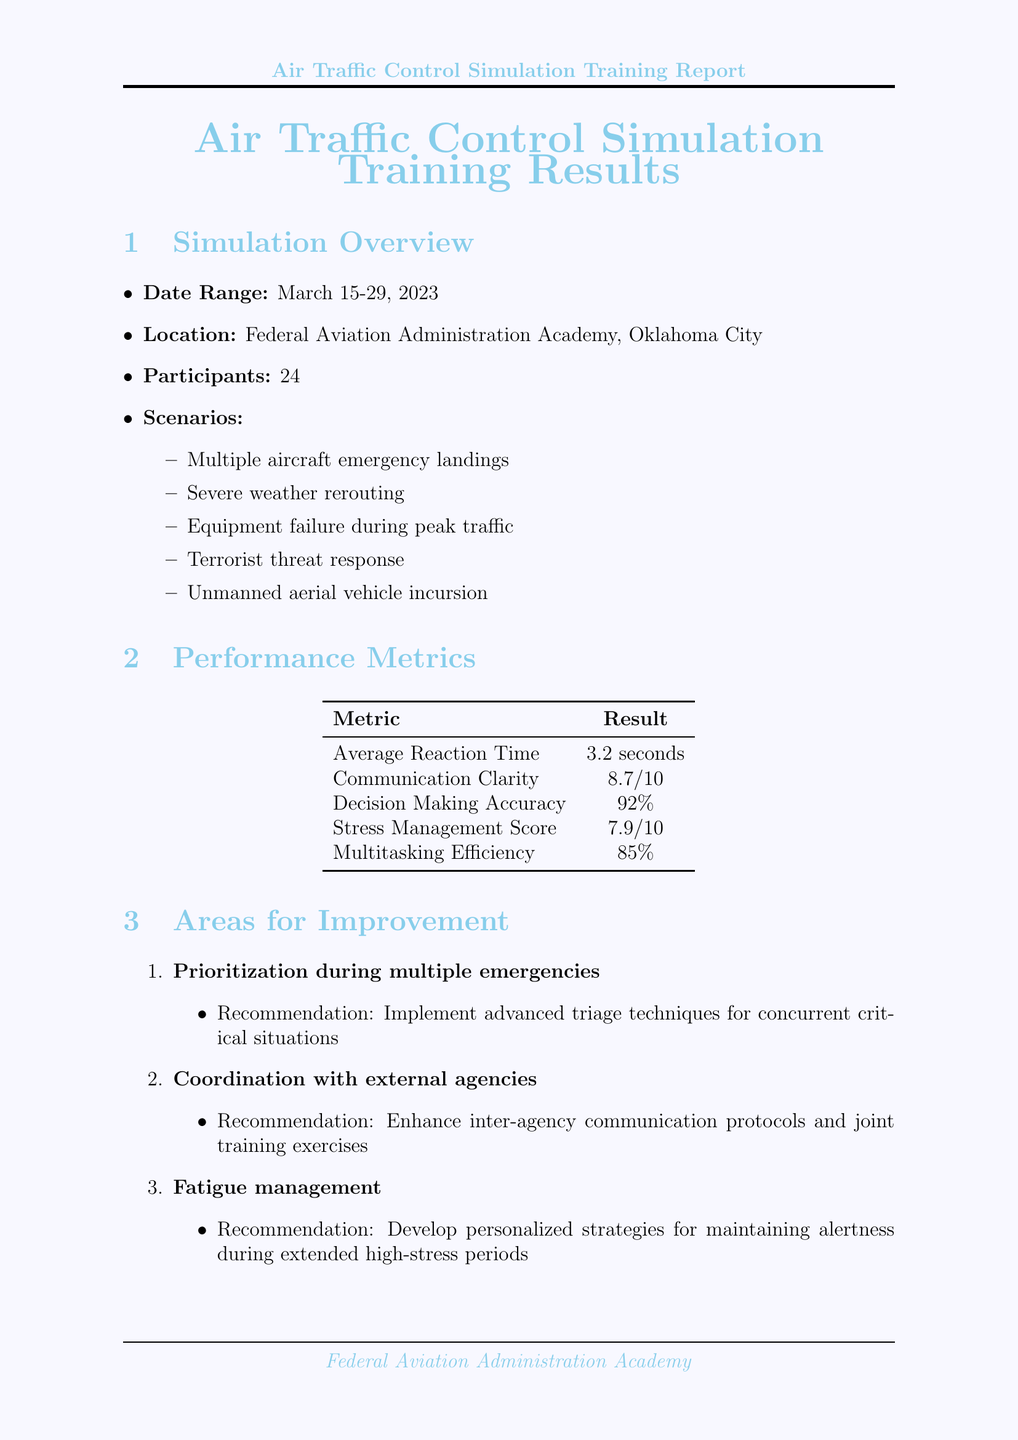What was the date range of the simulations? The date range is specified in the section titled "Simulation Overview," which details the period of the simulations as March 15-29, 2023.
Answer: March 15-29, 2023 What was the average reaction time reported? The average reaction time is mentioned in the "Performance Metrics" table and is a direct performance measure provided.
Answer: 3.2 seconds How many participants were involved in the simulations? The number of participants is listed in the "Simulation Overview" section and refers to the total count for the training.
Answer: 24 Which scenario received commendations for quick decision making? The commendation for quick decision making relates to the scenario that involved severe weather rerouting, as noted in the "Commendations" section.
Answer: Severe weather rerouting What recommendation is made for improving fatigue management? The report includes an area for improvement on fatigue management, which specifies a recommendation found in the "Areas for Improvement" section.
Answer: Develop personalized strategies for maintaining alertness during extended high-stress periods What technology was rated 9.1 out of 10? The effectiveness rating of 9.1/10 is given for the simulation software, labeled in the "Technology Assessment" section of the document.
Answer: BEST-ATC Pro v4.2 What is one of the future training focuses mentioned? The section labeled "Future Training Focus" lists several areas; one of them addresses a specific training focus and is relevant to developments in air traffic management.
Answer: Integration of artificial intelligence assistants in high-stress scenarios Who facilitated the stress management workshop? The document specifies the facilitator's name and profession under the post-simulation resources regarding the stress management workshop.
Answer: Dr. Emily Chen, Aviation Psychologist 